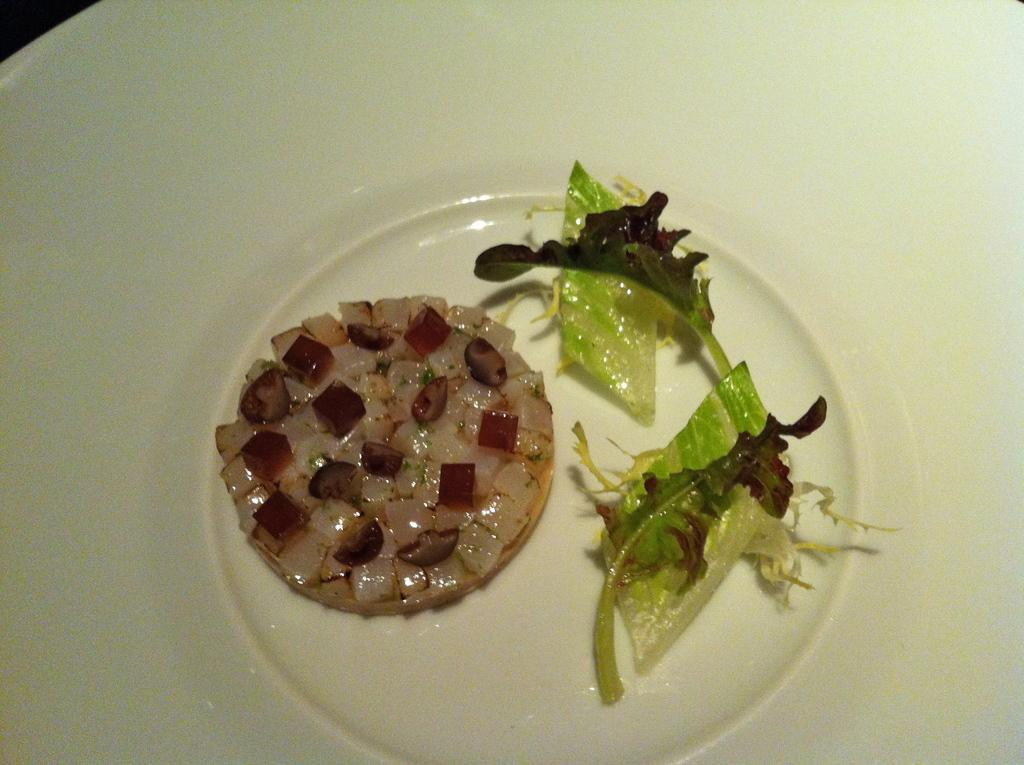What is present on the plate in the image? There is food on the plate in the image. What else can be seen near the plate? There are leaves beside the food. Who is the writer of the book seen on the plate in the image? There is no book present on the plate in the image. 